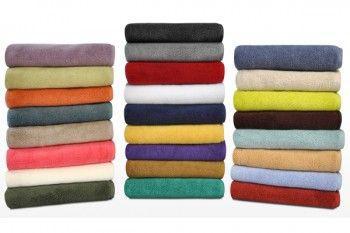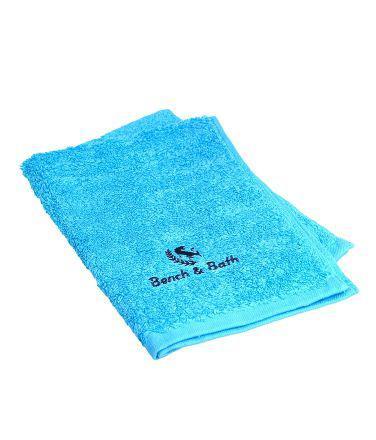The first image is the image on the left, the second image is the image on the right. For the images displayed, is the sentence "There are exactly five towels in the left image." factually correct? Answer yes or no. No. The first image is the image on the left, the second image is the image on the right. Assess this claim about the two images: "There is a single tower of five towels.". Correct or not? Answer yes or no. No. 